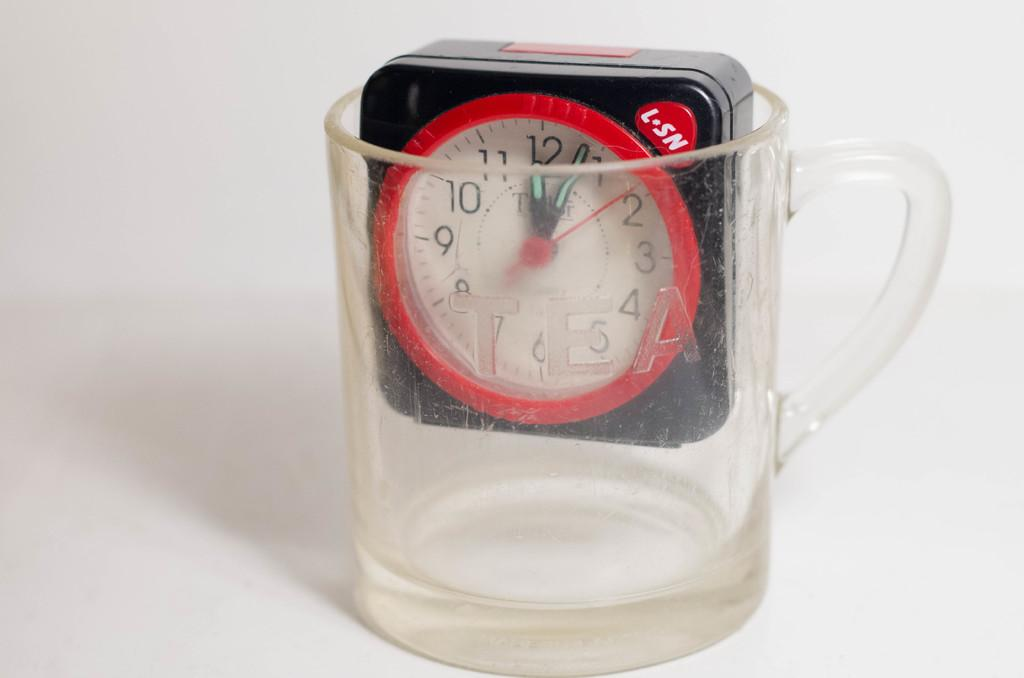Provide a one-sentence caption for the provided image. L-SN clock places inside an empty glass cup. 